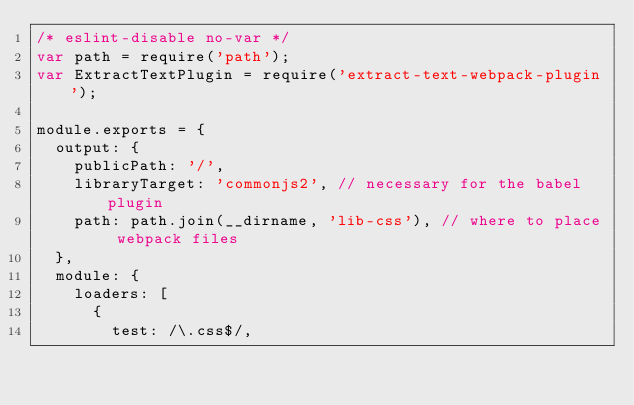<code> <loc_0><loc_0><loc_500><loc_500><_JavaScript_>/* eslint-disable no-var */
var path = require('path');
var ExtractTextPlugin = require('extract-text-webpack-plugin');

module.exports = {
  output: {
    publicPath: '/',
    libraryTarget: 'commonjs2', // necessary for the babel plugin
    path: path.join(__dirname, 'lib-css'), // where to place webpack files
  },
  module: {
    loaders: [
      {
        test: /\.css$/,</code> 